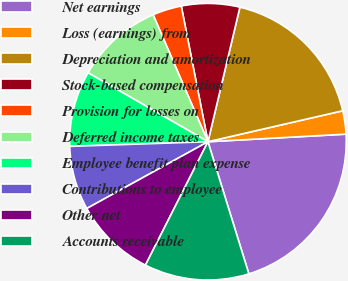Convert chart. <chart><loc_0><loc_0><loc_500><loc_500><pie_chart><fcel>Net earnings<fcel>Loss (earnings) from<fcel>Depreciation and amortization<fcel>Stock-based compensation<fcel>Provision for losses on<fcel>Deferred income taxes<fcel>Employee benefit plan expense<fcel>Contributions to employee<fcel>Other net<fcel>Accounts receivable<nl><fcel>21.09%<fcel>2.72%<fcel>17.69%<fcel>6.8%<fcel>3.4%<fcel>10.2%<fcel>8.84%<fcel>7.48%<fcel>9.52%<fcel>12.24%<nl></chart> 